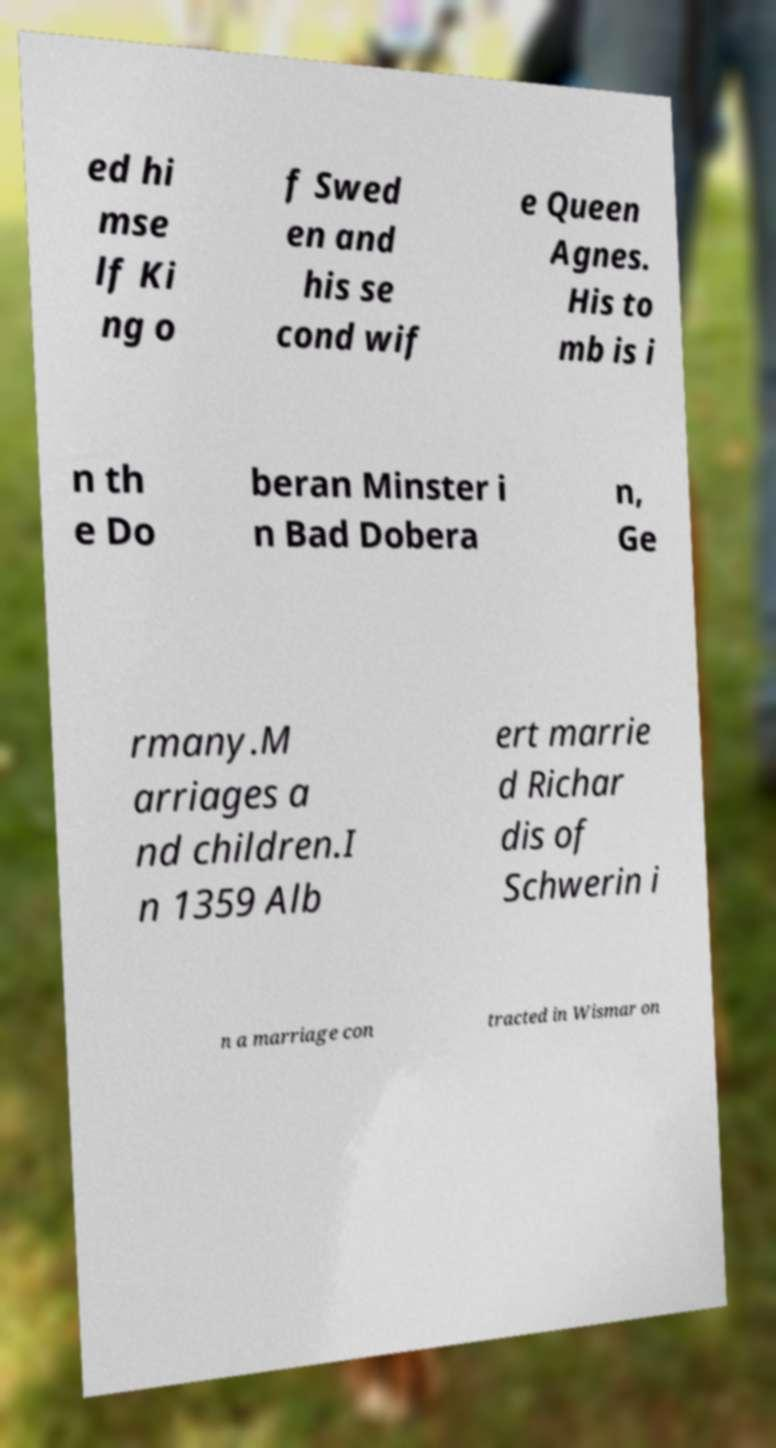Could you assist in decoding the text presented in this image and type it out clearly? ed hi mse lf Ki ng o f Swed en and his se cond wif e Queen Agnes. His to mb is i n th e Do beran Minster i n Bad Dobera n, Ge rmany.M arriages a nd children.I n 1359 Alb ert marrie d Richar dis of Schwerin i n a marriage con tracted in Wismar on 